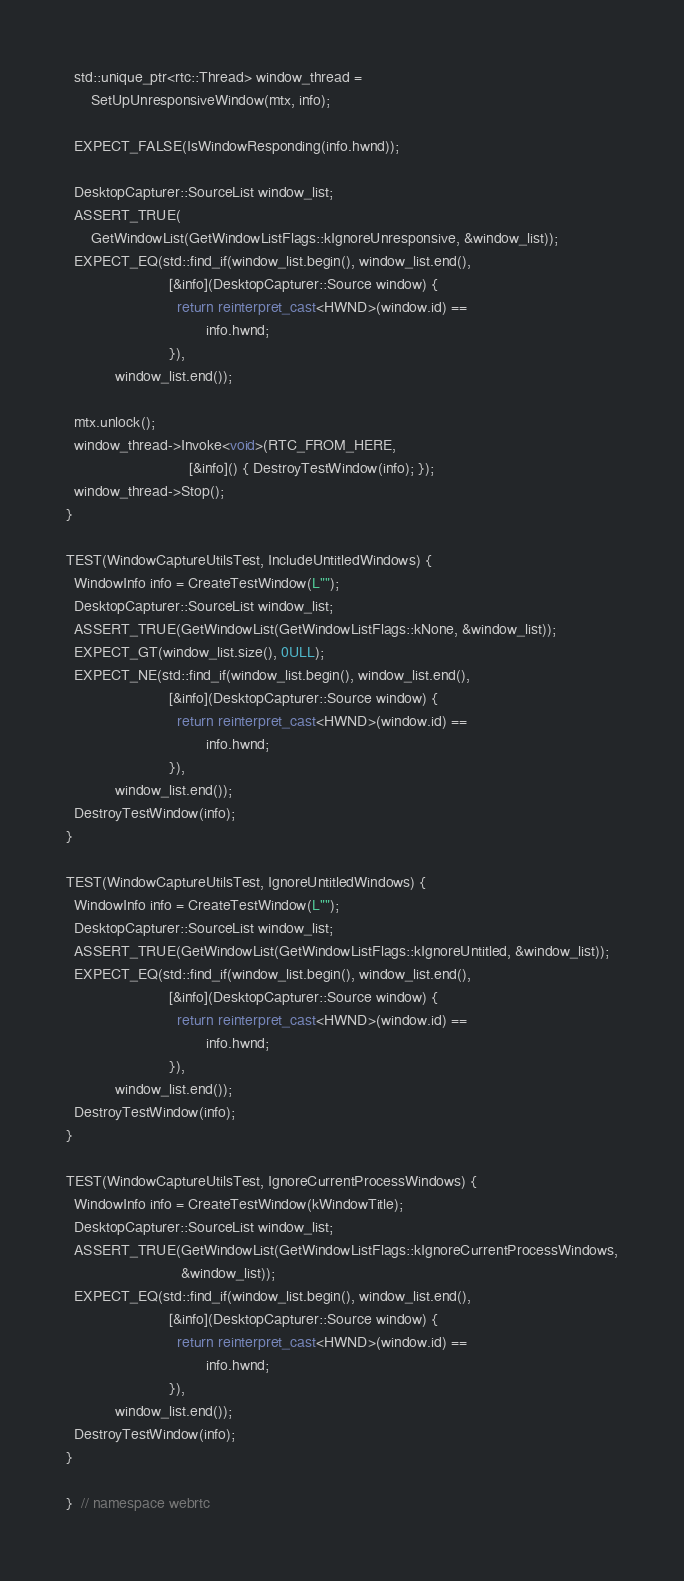Convert code to text. <code><loc_0><loc_0><loc_500><loc_500><_C++_>  std::unique_ptr<rtc::Thread> window_thread =
      SetUpUnresponsiveWindow(mtx, info);

  EXPECT_FALSE(IsWindowResponding(info.hwnd));

  DesktopCapturer::SourceList window_list;
  ASSERT_TRUE(
      GetWindowList(GetWindowListFlags::kIgnoreUnresponsive, &window_list));
  EXPECT_EQ(std::find_if(window_list.begin(), window_list.end(),
                         [&info](DesktopCapturer::Source window) {
                           return reinterpret_cast<HWND>(window.id) ==
                                  info.hwnd;
                         }),
            window_list.end());

  mtx.unlock();
  window_thread->Invoke<void>(RTC_FROM_HERE,
                              [&info]() { DestroyTestWindow(info); });
  window_thread->Stop();
}

TEST(WindowCaptureUtilsTest, IncludeUntitledWindows) {
  WindowInfo info = CreateTestWindow(L"");
  DesktopCapturer::SourceList window_list;
  ASSERT_TRUE(GetWindowList(GetWindowListFlags::kNone, &window_list));
  EXPECT_GT(window_list.size(), 0ULL);
  EXPECT_NE(std::find_if(window_list.begin(), window_list.end(),
                         [&info](DesktopCapturer::Source window) {
                           return reinterpret_cast<HWND>(window.id) ==
                                  info.hwnd;
                         }),
            window_list.end());
  DestroyTestWindow(info);
}

TEST(WindowCaptureUtilsTest, IgnoreUntitledWindows) {
  WindowInfo info = CreateTestWindow(L"");
  DesktopCapturer::SourceList window_list;
  ASSERT_TRUE(GetWindowList(GetWindowListFlags::kIgnoreUntitled, &window_list));
  EXPECT_EQ(std::find_if(window_list.begin(), window_list.end(),
                         [&info](DesktopCapturer::Source window) {
                           return reinterpret_cast<HWND>(window.id) ==
                                  info.hwnd;
                         }),
            window_list.end());
  DestroyTestWindow(info);
}

TEST(WindowCaptureUtilsTest, IgnoreCurrentProcessWindows) {
  WindowInfo info = CreateTestWindow(kWindowTitle);
  DesktopCapturer::SourceList window_list;
  ASSERT_TRUE(GetWindowList(GetWindowListFlags::kIgnoreCurrentProcessWindows,
                            &window_list));
  EXPECT_EQ(std::find_if(window_list.begin(), window_list.end(),
                         [&info](DesktopCapturer::Source window) {
                           return reinterpret_cast<HWND>(window.id) ==
                                  info.hwnd;
                         }),
            window_list.end());
  DestroyTestWindow(info);
}

}  // namespace webrtc
</code> 